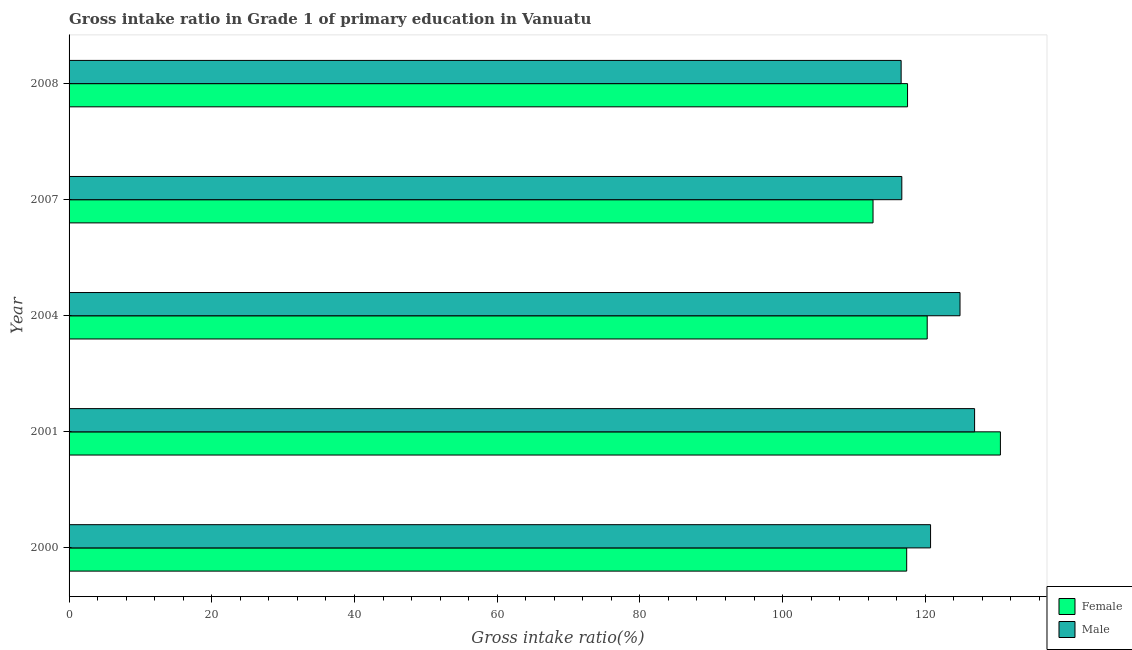How many groups of bars are there?
Offer a terse response. 5. Are the number of bars on each tick of the Y-axis equal?
Provide a short and direct response. Yes. How many bars are there on the 3rd tick from the top?
Your answer should be compact. 2. What is the label of the 4th group of bars from the top?
Keep it short and to the point. 2001. In how many cases, is the number of bars for a given year not equal to the number of legend labels?
Ensure brevity in your answer.  0. What is the gross intake ratio(female) in 2000?
Your answer should be very brief. 117.39. Across all years, what is the maximum gross intake ratio(female)?
Your response must be concise. 130.52. Across all years, what is the minimum gross intake ratio(female)?
Provide a short and direct response. 112.67. What is the total gross intake ratio(female) in the graph?
Give a very brief answer. 598.36. What is the difference between the gross intake ratio(male) in 2000 and that in 2007?
Your answer should be compact. 4.03. What is the difference between the gross intake ratio(female) in 2008 and the gross intake ratio(male) in 2004?
Keep it short and to the point. -7.35. What is the average gross intake ratio(male) per year?
Your answer should be compact. 121.16. In the year 2000, what is the difference between the gross intake ratio(female) and gross intake ratio(male)?
Give a very brief answer. -3.35. In how many years, is the gross intake ratio(female) greater than 112 %?
Provide a short and direct response. 5. What is the ratio of the gross intake ratio(female) in 2007 to that in 2008?
Make the answer very short. 0.96. Is the gross intake ratio(male) in 2000 less than that in 2004?
Provide a short and direct response. Yes. What is the difference between the highest and the second highest gross intake ratio(female)?
Your answer should be compact. 10.26. What is the difference between the highest and the lowest gross intake ratio(male)?
Ensure brevity in your answer.  10.29. What does the 1st bar from the bottom in 2000 represents?
Your response must be concise. Female. Where does the legend appear in the graph?
Ensure brevity in your answer.  Bottom right. What is the title of the graph?
Offer a very short reply. Gross intake ratio in Grade 1 of primary education in Vanuatu. Does "Net National savings" appear as one of the legend labels in the graph?
Provide a short and direct response. No. What is the label or title of the X-axis?
Give a very brief answer. Gross intake ratio(%). What is the Gross intake ratio(%) in Female in 2000?
Make the answer very short. 117.39. What is the Gross intake ratio(%) of Male in 2000?
Provide a succinct answer. 120.73. What is the Gross intake ratio(%) in Female in 2001?
Provide a short and direct response. 130.52. What is the Gross intake ratio(%) in Male in 2001?
Your response must be concise. 126.9. What is the Gross intake ratio(%) in Female in 2004?
Offer a very short reply. 120.26. What is the Gross intake ratio(%) of Male in 2004?
Offer a terse response. 124.86. What is the Gross intake ratio(%) of Female in 2007?
Offer a very short reply. 112.67. What is the Gross intake ratio(%) in Male in 2007?
Your answer should be compact. 116.71. What is the Gross intake ratio(%) of Female in 2008?
Make the answer very short. 117.51. What is the Gross intake ratio(%) of Male in 2008?
Your answer should be compact. 116.61. Across all years, what is the maximum Gross intake ratio(%) in Female?
Your answer should be compact. 130.52. Across all years, what is the maximum Gross intake ratio(%) of Male?
Offer a very short reply. 126.9. Across all years, what is the minimum Gross intake ratio(%) in Female?
Offer a very short reply. 112.67. Across all years, what is the minimum Gross intake ratio(%) of Male?
Give a very brief answer. 116.61. What is the total Gross intake ratio(%) of Female in the graph?
Provide a short and direct response. 598.36. What is the total Gross intake ratio(%) in Male in the graph?
Provide a short and direct response. 605.82. What is the difference between the Gross intake ratio(%) in Female in 2000 and that in 2001?
Make the answer very short. -13.14. What is the difference between the Gross intake ratio(%) in Male in 2000 and that in 2001?
Provide a short and direct response. -6.17. What is the difference between the Gross intake ratio(%) in Female in 2000 and that in 2004?
Your answer should be very brief. -2.88. What is the difference between the Gross intake ratio(%) in Male in 2000 and that in 2004?
Your answer should be very brief. -4.13. What is the difference between the Gross intake ratio(%) of Female in 2000 and that in 2007?
Make the answer very short. 4.72. What is the difference between the Gross intake ratio(%) of Male in 2000 and that in 2007?
Ensure brevity in your answer.  4.03. What is the difference between the Gross intake ratio(%) of Female in 2000 and that in 2008?
Give a very brief answer. -0.12. What is the difference between the Gross intake ratio(%) in Male in 2000 and that in 2008?
Offer a terse response. 4.12. What is the difference between the Gross intake ratio(%) of Female in 2001 and that in 2004?
Provide a succinct answer. 10.26. What is the difference between the Gross intake ratio(%) in Male in 2001 and that in 2004?
Your answer should be compact. 2.04. What is the difference between the Gross intake ratio(%) of Female in 2001 and that in 2007?
Ensure brevity in your answer.  17.85. What is the difference between the Gross intake ratio(%) of Male in 2001 and that in 2007?
Your response must be concise. 10.2. What is the difference between the Gross intake ratio(%) in Female in 2001 and that in 2008?
Keep it short and to the point. 13.01. What is the difference between the Gross intake ratio(%) of Male in 2001 and that in 2008?
Provide a succinct answer. 10.29. What is the difference between the Gross intake ratio(%) of Female in 2004 and that in 2007?
Your answer should be compact. 7.59. What is the difference between the Gross intake ratio(%) of Male in 2004 and that in 2007?
Offer a terse response. 8.16. What is the difference between the Gross intake ratio(%) of Female in 2004 and that in 2008?
Offer a terse response. 2.76. What is the difference between the Gross intake ratio(%) of Male in 2004 and that in 2008?
Your answer should be very brief. 8.25. What is the difference between the Gross intake ratio(%) in Female in 2007 and that in 2008?
Ensure brevity in your answer.  -4.84. What is the difference between the Gross intake ratio(%) of Male in 2007 and that in 2008?
Offer a terse response. 0.09. What is the difference between the Gross intake ratio(%) in Female in 2000 and the Gross intake ratio(%) in Male in 2001?
Your response must be concise. -9.52. What is the difference between the Gross intake ratio(%) of Female in 2000 and the Gross intake ratio(%) of Male in 2004?
Provide a succinct answer. -7.47. What is the difference between the Gross intake ratio(%) in Female in 2000 and the Gross intake ratio(%) in Male in 2007?
Your answer should be compact. 0.68. What is the difference between the Gross intake ratio(%) in Female in 2000 and the Gross intake ratio(%) in Male in 2008?
Ensure brevity in your answer.  0.78. What is the difference between the Gross intake ratio(%) of Female in 2001 and the Gross intake ratio(%) of Male in 2004?
Provide a succinct answer. 5.66. What is the difference between the Gross intake ratio(%) of Female in 2001 and the Gross intake ratio(%) of Male in 2007?
Make the answer very short. 13.82. What is the difference between the Gross intake ratio(%) of Female in 2001 and the Gross intake ratio(%) of Male in 2008?
Your answer should be compact. 13.91. What is the difference between the Gross intake ratio(%) of Female in 2004 and the Gross intake ratio(%) of Male in 2007?
Provide a succinct answer. 3.56. What is the difference between the Gross intake ratio(%) in Female in 2004 and the Gross intake ratio(%) in Male in 2008?
Give a very brief answer. 3.65. What is the difference between the Gross intake ratio(%) in Female in 2007 and the Gross intake ratio(%) in Male in 2008?
Keep it short and to the point. -3.94. What is the average Gross intake ratio(%) in Female per year?
Give a very brief answer. 119.67. What is the average Gross intake ratio(%) of Male per year?
Offer a very short reply. 121.16. In the year 2000, what is the difference between the Gross intake ratio(%) in Female and Gross intake ratio(%) in Male?
Keep it short and to the point. -3.35. In the year 2001, what is the difference between the Gross intake ratio(%) in Female and Gross intake ratio(%) in Male?
Provide a short and direct response. 3.62. In the year 2004, what is the difference between the Gross intake ratio(%) in Female and Gross intake ratio(%) in Male?
Your answer should be compact. -4.6. In the year 2007, what is the difference between the Gross intake ratio(%) in Female and Gross intake ratio(%) in Male?
Your response must be concise. -4.03. In the year 2008, what is the difference between the Gross intake ratio(%) of Female and Gross intake ratio(%) of Male?
Offer a very short reply. 0.9. What is the ratio of the Gross intake ratio(%) in Female in 2000 to that in 2001?
Offer a terse response. 0.9. What is the ratio of the Gross intake ratio(%) of Male in 2000 to that in 2001?
Make the answer very short. 0.95. What is the ratio of the Gross intake ratio(%) in Female in 2000 to that in 2004?
Provide a short and direct response. 0.98. What is the ratio of the Gross intake ratio(%) of Male in 2000 to that in 2004?
Make the answer very short. 0.97. What is the ratio of the Gross intake ratio(%) of Female in 2000 to that in 2007?
Your response must be concise. 1.04. What is the ratio of the Gross intake ratio(%) of Male in 2000 to that in 2007?
Keep it short and to the point. 1.03. What is the ratio of the Gross intake ratio(%) of Female in 2000 to that in 2008?
Keep it short and to the point. 1. What is the ratio of the Gross intake ratio(%) of Male in 2000 to that in 2008?
Provide a succinct answer. 1.04. What is the ratio of the Gross intake ratio(%) in Female in 2001 to that in 2004?
Offer a terse response. 1.09. What is the ratio of the Gross intake ratio(%) in Male in 2001 to that in 2004?
Keep it short and to the point. 1.02. What is the ratio of the Gross intake ratio(%) in Female in 2001 to that in 2007?
Your response must be concise. 1.16. What is the ratio of the Gross intake ratio(%) of Male in 2001 to that in 2007?
Your response must be concise. 1.09. What is the ratio of the Gross intake ratio(%) of Female in 2001 to that in 2008?
Your response must be concise. 1.11. What is the ratio of the Gross intake ratio(%) in Male in 2001 to that in 2008?
Make the answer very short. 1.09. What is the ratio of the Gross intake ratio(%) in Female in 2004 to that in 2007?
Your answer should be compact. 1.07. What is the ratio of the Gross intake ratio(%) in Male in 2004 to that in 2007?
Keep it short and to the point. 1.07. What is the ratio of the Gross intake ratio(%) of Female in 2004 to that in 2008?
Provide a succinct answer. 1.02. What is the ratio of the Gross intake ratio(%) in Male in 2004 to that in 2008?
Keep it short and to the point. 1.07. What is the ratio of the Gross intake ratio(%) of Female in 2007 to that in 2008?
Your response must be concise. 0.96. What is the difference between the highest and the second highest Gross intake ratio(%) of Female?
Offer a very short reply. 10.26. What is the difference between the highest and the second highest Gross intake ratio(%) of Male?
Offer a very short reply. 2.04. What is the difference between the highest and the lowest Gross intake ratio(%) in Female?
Provide a succinct answer. 17.85. What is the difference between the highest and the lowest Gross intake ratio(%) of Male?
Ensure brevity in your answer.  10.29. 